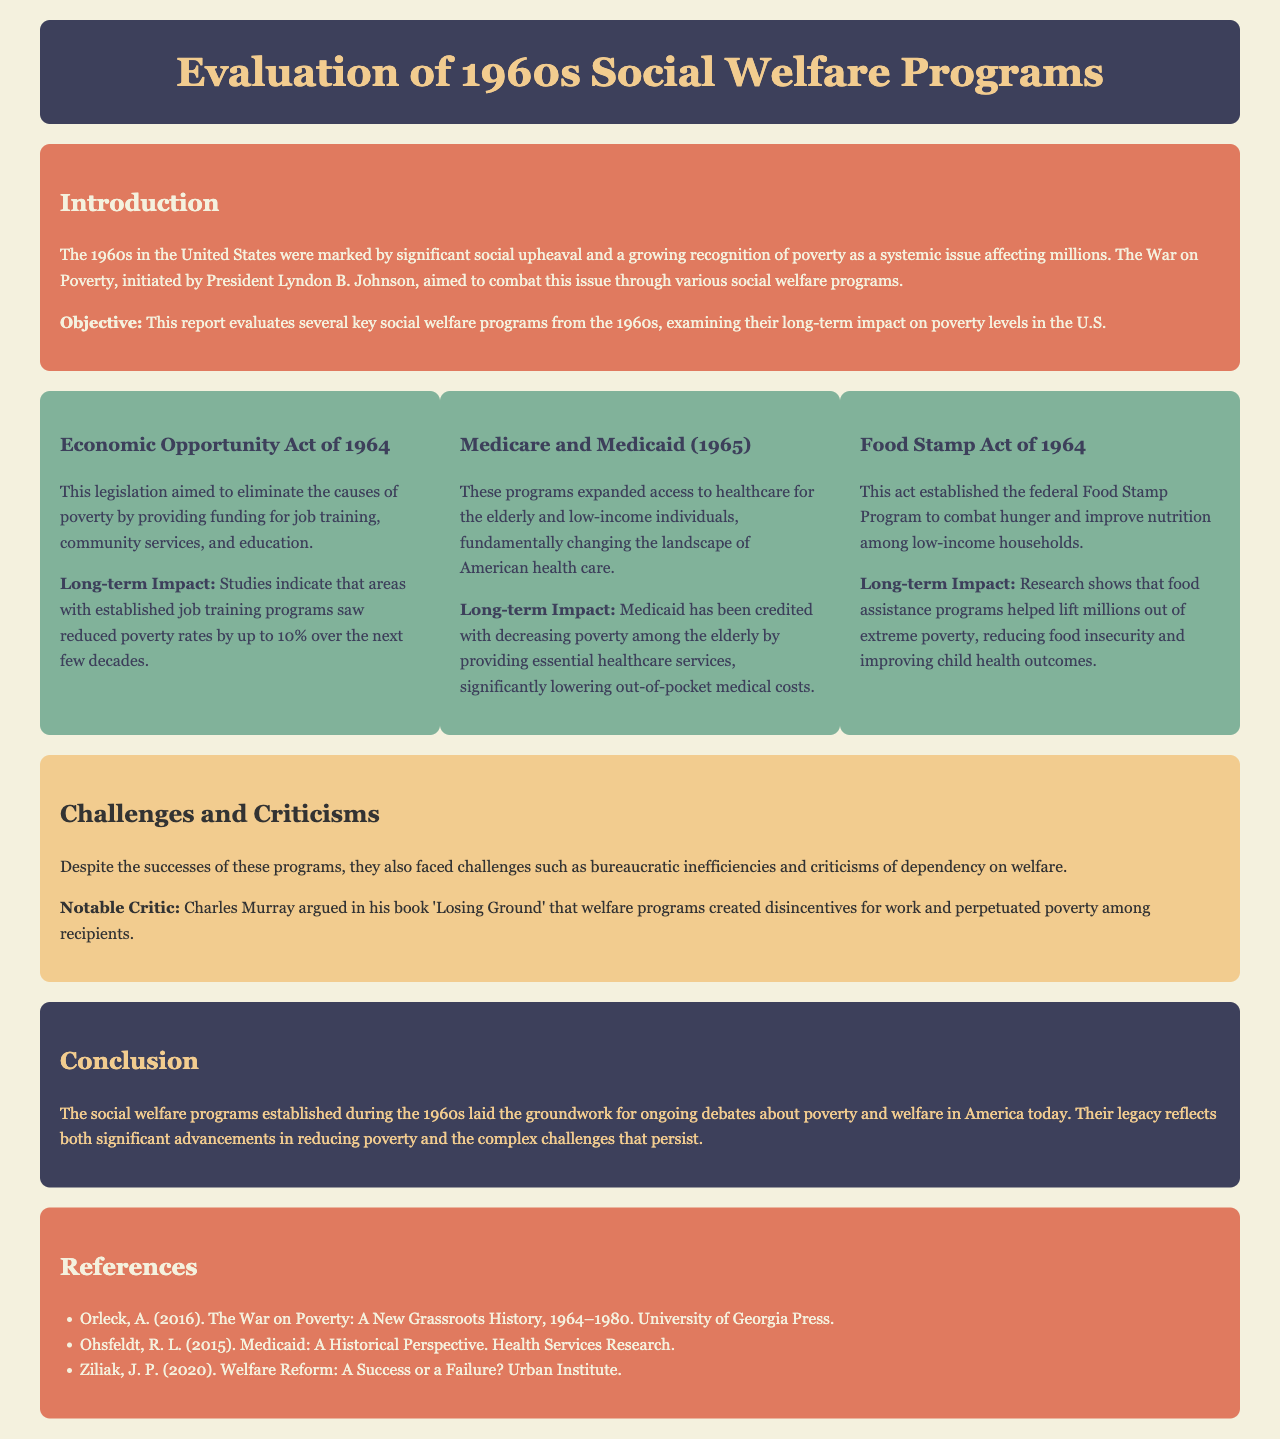what was the primary objective of the report? The report aims to evaluate several key social welfare programs from the 1960s and examine their long-term impact on poverty levels in the U.S.
Answer: evaluate several key social welfare programs what year was the Economic Opportunity Act established? The Economic Opportunity Act was established in 1964.
Answer: 1964 how much did poverty rates decrease in areas with job training programs? Areas with established job training programs saw reduced poverty rates by up to 10% over the next few decades.
Answer: 10% which program was credited with decreasing poverty among the elderly? Medicaid is credited with decreasing poverty among the elderly.
Answer: Medicaid what significant criticism did Charles Murray present about welfare programs? Charles Murray argued that welfare programs created disincentives for work and perpetuated poverty among recipients.
Answer: disincentives for work what is a notable act aimed at combating hunger established in 1964? The Food Stamp Act of 1964 is aimed at combating hunger.
Answer: Food Stamp Act of 1964 who is the author of "The War on Poverty: A New Grassroots History, 1964–1980"? The author of this work is Annelise Orleck.
Answer: Annelise Orleck what significant healthcare programs were introduced in 1965? Medicare and Medicaid were introduced in 1965.
Answer: Medicare and Medicaid what two key challenges did the social welfare programs face? The programs faced bureaucratic inefficiencies and criticisms of dependency on welfare.
Answer: bureaucratic inefficiencies and criticisms of dependency 